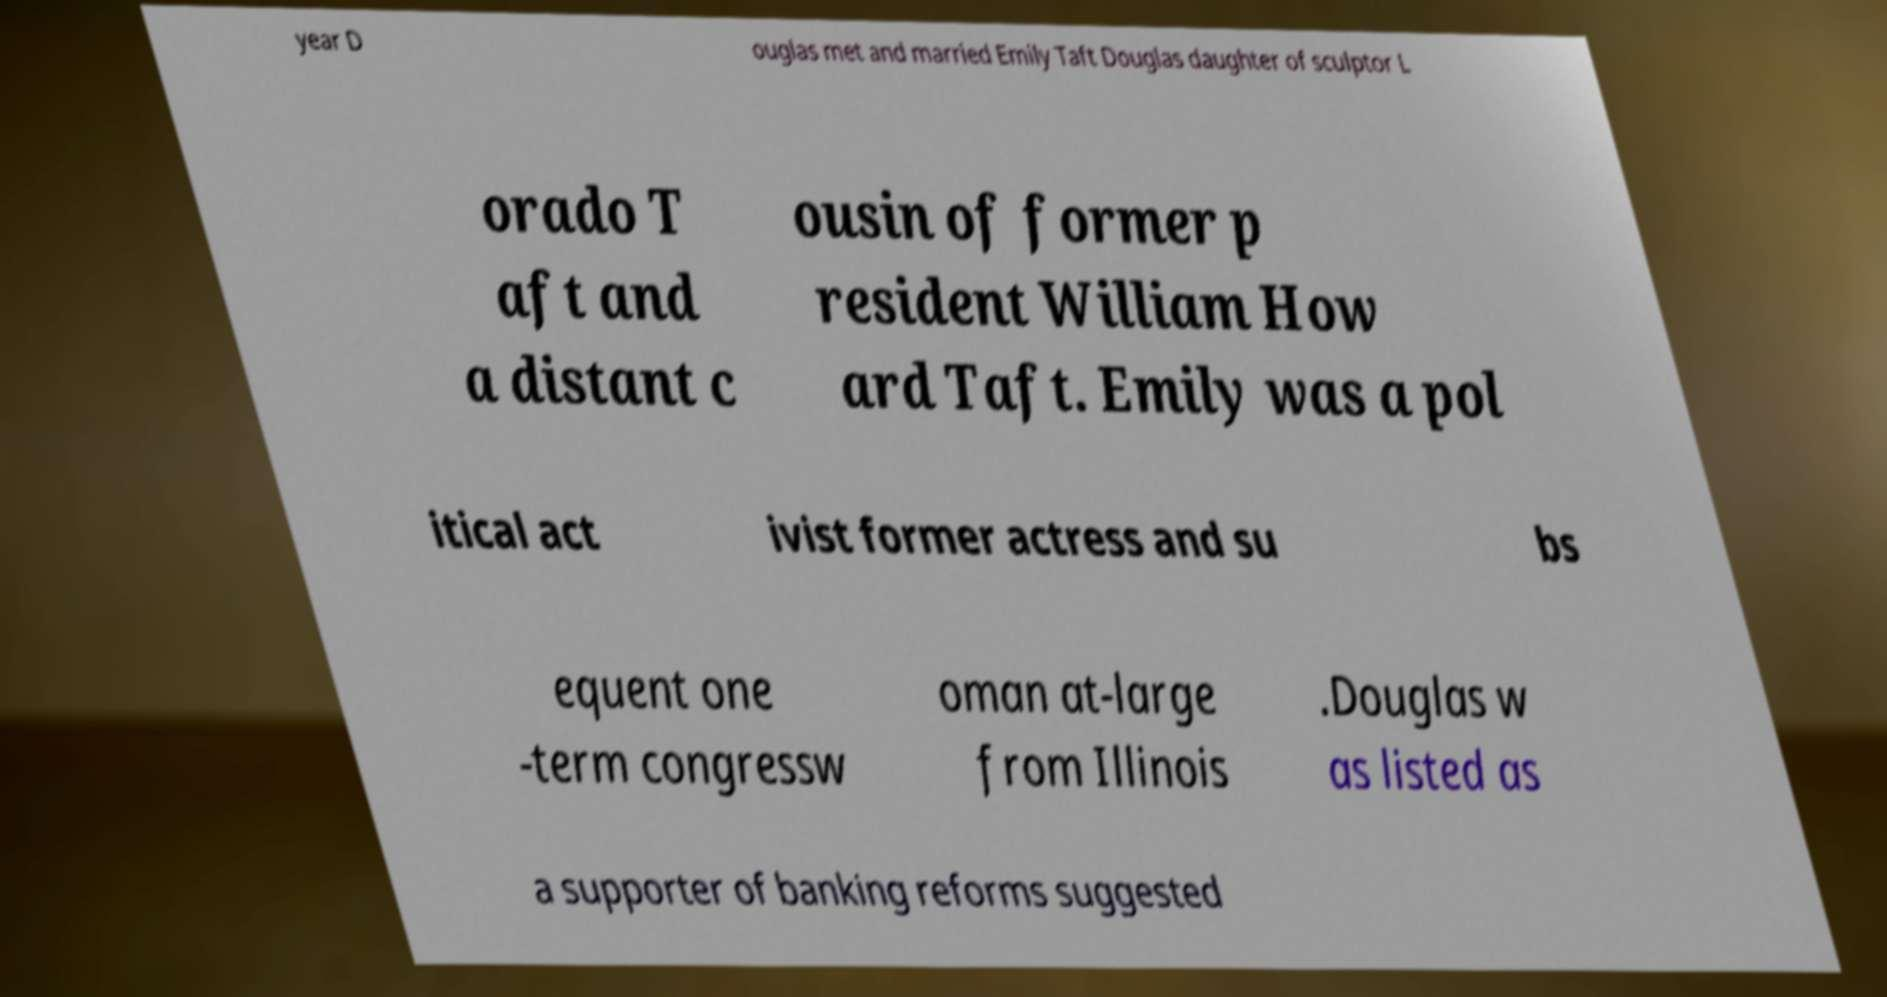Please read and relay the text visible in this image. What does it say? year D ouglas met and married Emily Taft Douglas daughter of sculptor L orado T aft and a distant c ousin of former p resident William How ard Taft. Emily was a pol itical act ivist former actress and su bs equent one -term congressw oman at-large from Illinois .Douglas w as listed as a supporter of banking reforms suggested 